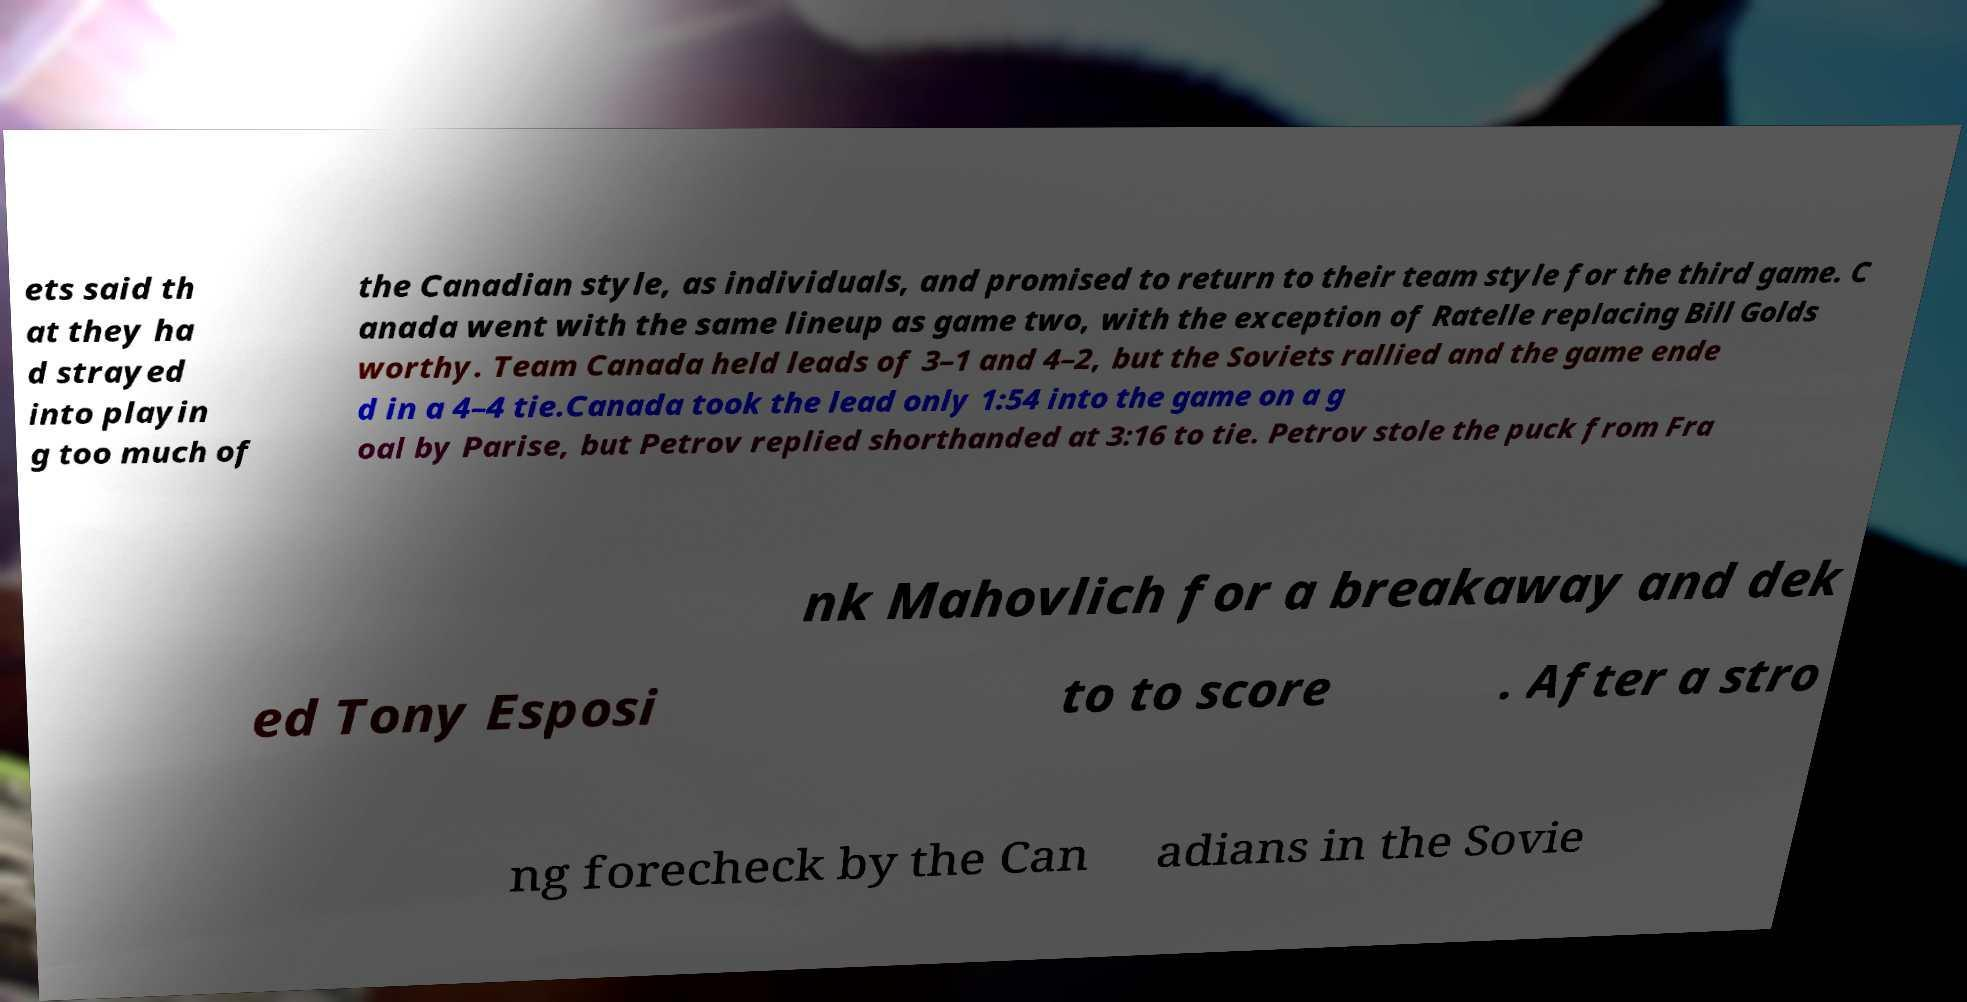What messages or text are displayed in this image? I need them in a readable, typed format. ets said th at they ha d strayed into playin g too much of the Canadian style, as individuals, and promised to return to their team style for the third game. C anada went with the same lineup as game two, with the exception of Ratelle replacing Bill Golds worthy. Team Canada held leads of 3–1 and 4–2, but the Soviets rallied and the game ende d in a 4–4 tie.Canada took the lead only 1:54 into the game on a g oal by Parise, but Petrov replied shorthanded at 3:16 to tie. Petrov stole the puck from Fra nk Mahovlich for a breakaway and dek ed Tony Esposi to to score . After a stro ng forecheck by the Can adians in the Sovie 